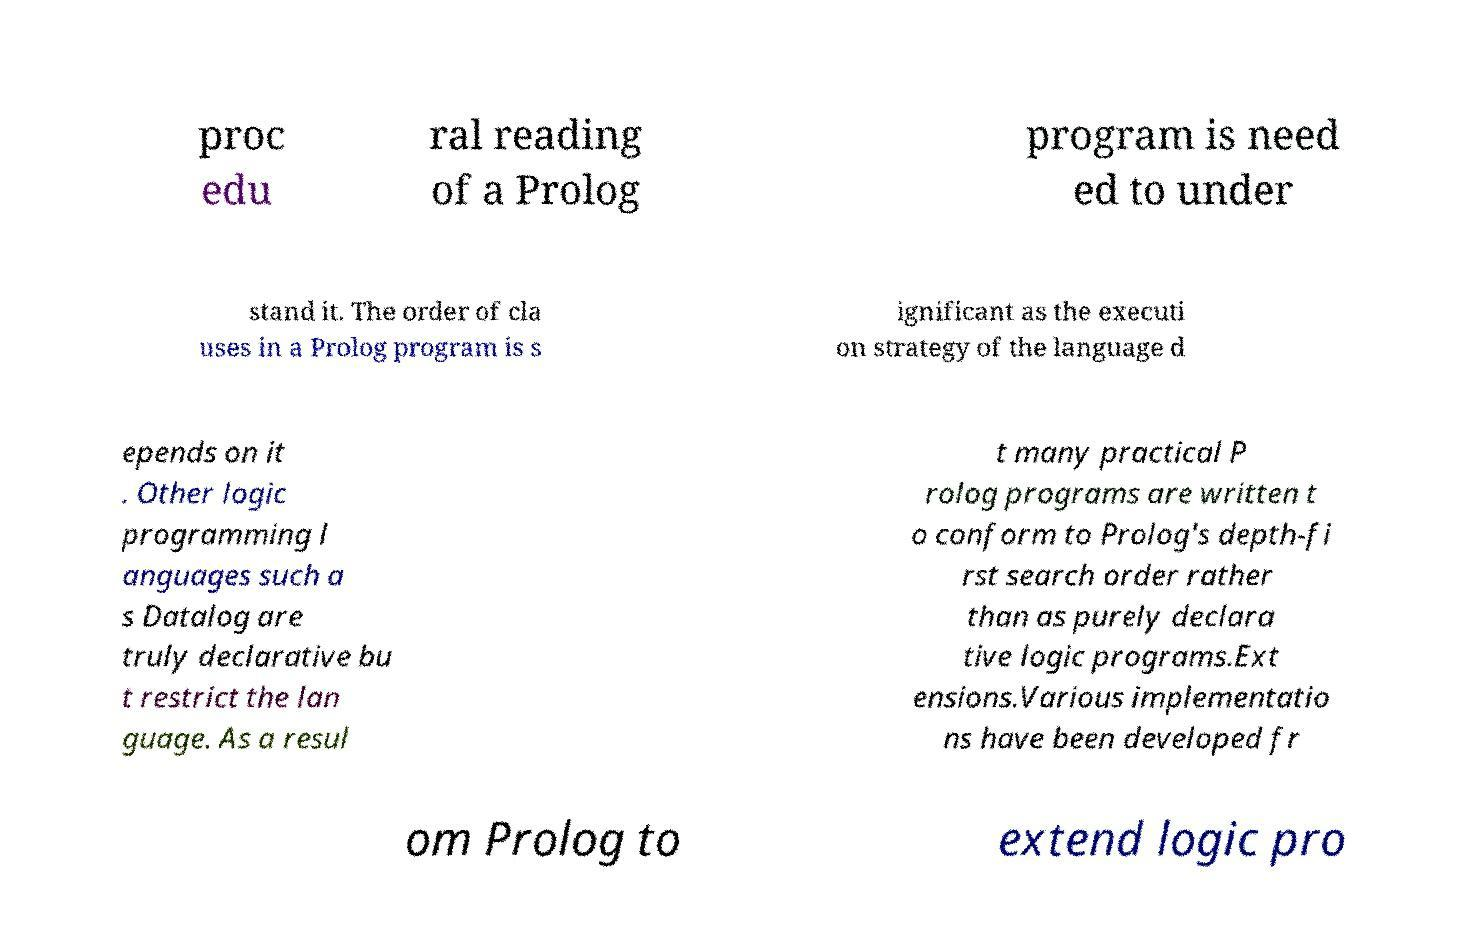Could you extract and type out the text from this image? proc edu ral reading of a Prolog program is need ed to under stand it. The order of cla uses in a Prolog program is s ignificant as the executi on strategy of the language d epends on it . Other logic programming l anguages such a s Datalog are truly declarative bu t restrict the lan guage. As a resul t many practical P rolog programs are written t o conform to Prolog's depth-fi rst search order rather than as purely declara tive logic programs.Ext ensions.Various implementatio ns have been developed fr om Prolog to extend logic pro 